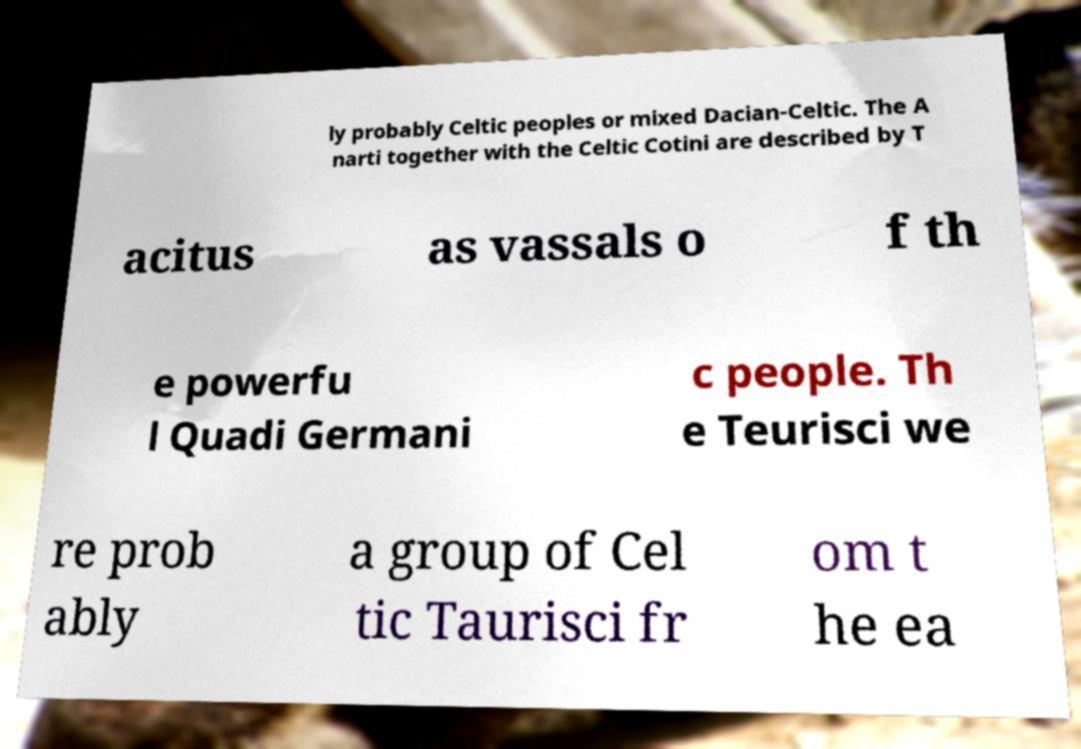Could you extract and type out the text from this image? ly probably Celtic peoples or mixed Dacian-Celtic. The A narti together with the Celtic Cotini are described by T acitus as vassals o f th e powerfu l Quadi Germani c people. Th e Teurisci we re prob ably a group of Cel tic Taurisci fr om t he ea 